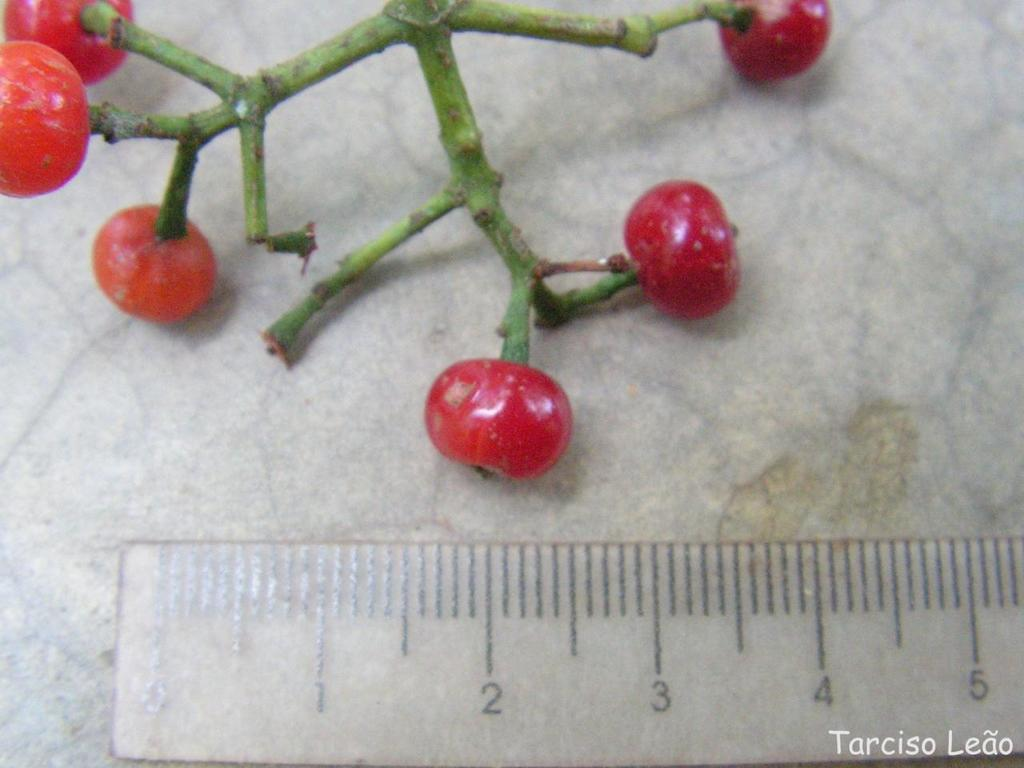<image>
Write a terse but informative summary of the picture. A ruler next to some berries was documented by Tarciso Leao. 